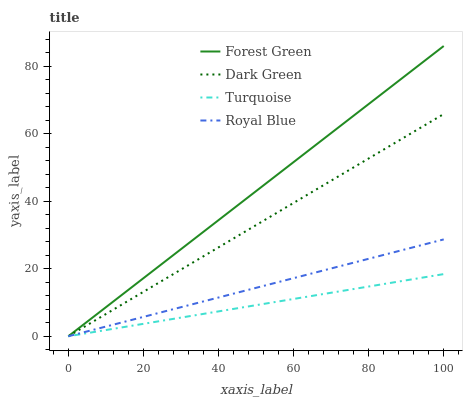Does Turquoise have the minimum area under the curve?
Answer yes or no. Yes. Does Forest Green have the maximum area under the curve?
Answer yes or no. Yes. Does Forest Green have the minimum area under the curve?
Answer yes or no. No. Does Turquoise have the maximum area under the curve?
Answer yes or no. No. Is Royal Blue the smoothest?
Answer yes or no. Yes. Is Forest Green the roughest?
Answer yes or no. Yes. Is Turquoise the smoothest?
Answer yes or no. No. Is Turquoise the roughest?
Answer yes or no. No. Does Royal Blue have the lowest value?
Answer yes or no. Yes. Does Forest Green have the highest value?
Answer yes or no. Yes. Does Turquoise have the highest value?
Answer yes or no. No. Does Forest Green intersect Dark Green?
Answer yes or no. Yes. Is Forest Green less than Dark Green?
Answer yes or no. No. Is Forest Green greater than Dark Green?
Answer yes or no. No. 